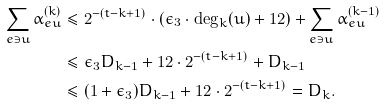<formula> <loc_0><loc_0><loc_500><loc_500>\sum _ { e \ni u } \alpha ^ { ( k ) } _ { e u } & \leq 2 ^ { - ( t - k + 1 ) } \cdot ( \epsilon _ { 3 } \cdot \deg _ { k } ( u ) + 1 2 ) + \sum _ { e \ni u } \alpha ^ { ( k - 1 ) } _ { e u } \\ & \leq \epsilon _ { 3 } D _ { k - 1 } + 1 2 \cdot 2 ^ { - ( t - k + 1 ) } + D _ { k - 1 } & & \\ & \leq ( 1 + \epsilon _ { 3 } ) D _ { k - 1 } + 1 2 \cdot 2 ^ { - ( t - k + 1 ) } = D _ { k } .</formula> 